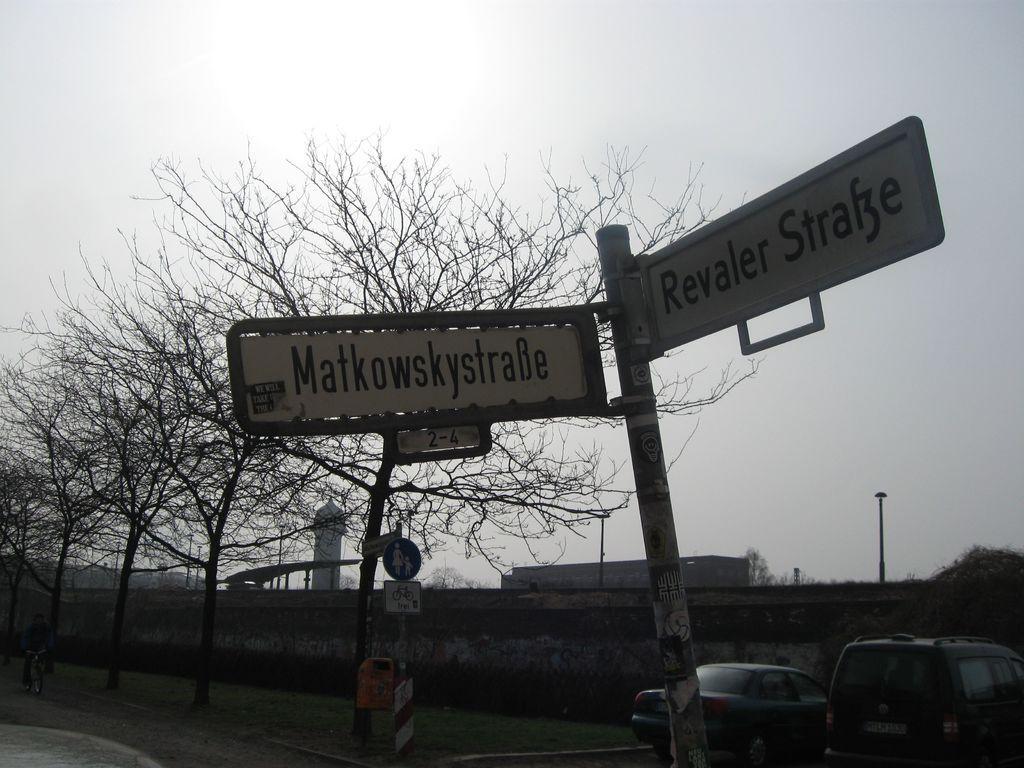Can you describe this image briefly? In this picture we can see a few vehicles on the right side. There are a few direction boards on the pole. We can see a few signboards on the path. A person is riding on a bicycle on the left side. There are a few trees and a white object in the background. 